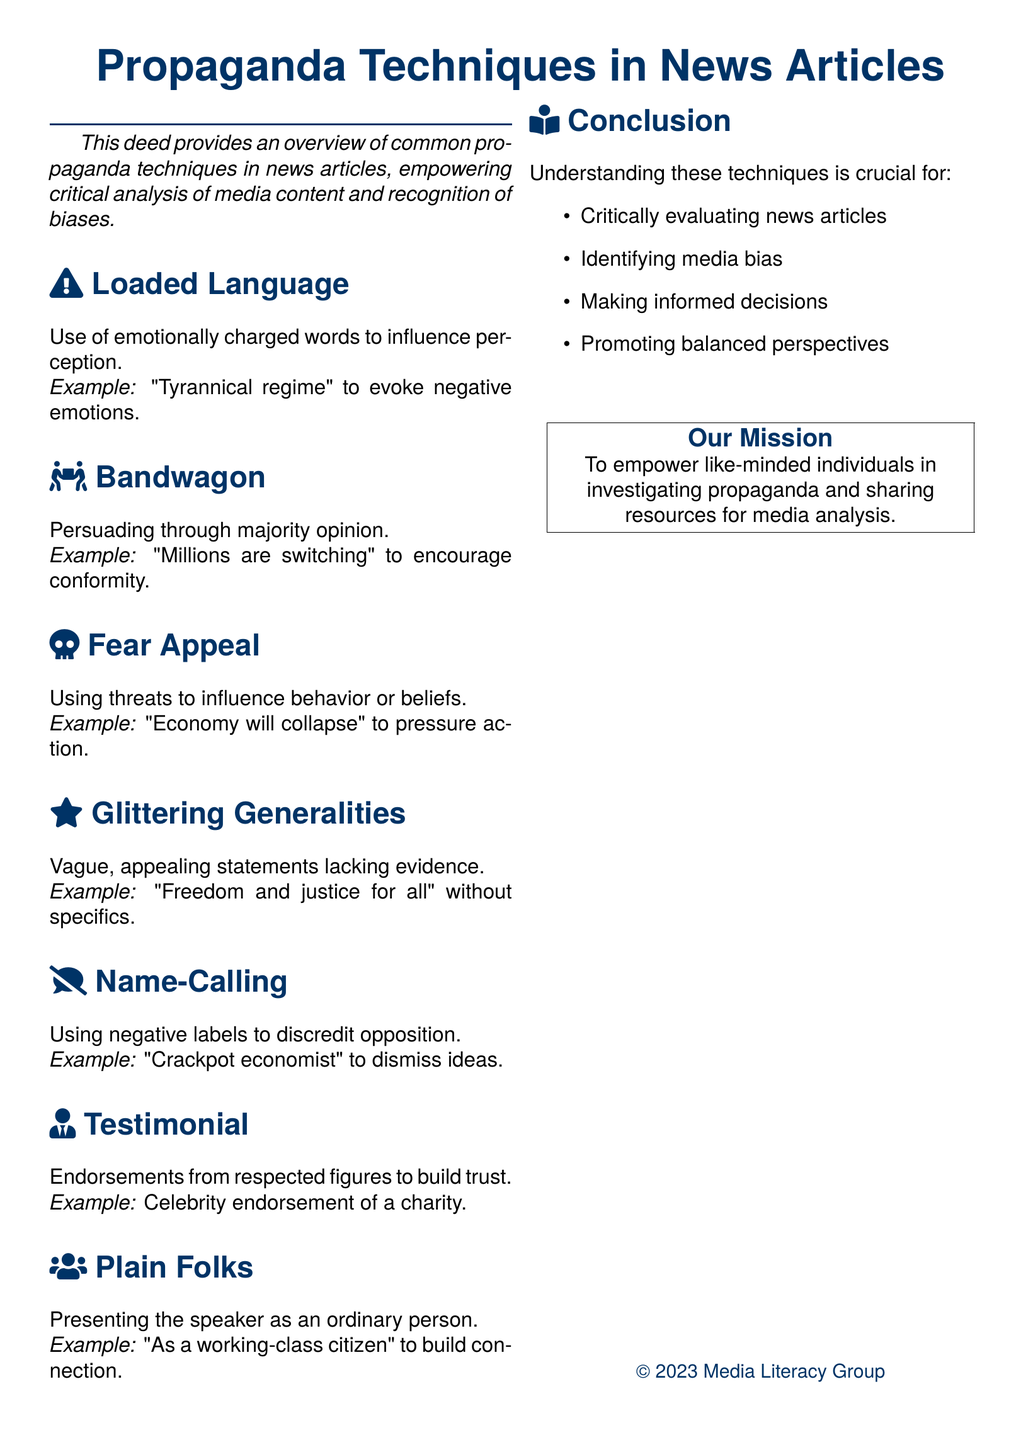What is the title of the document? The title is prominently displayed at the center of the document.
Answer: Propaganda Techniques in News Articles What technique involves the use of emotionally charged words? This technique is explicitly named in the document with an example provided.
Answer: Loaded Language Which example is given for the Bandwagon technique? A specific phrase is mentioned to illustrate the Bandwagon technique.
Answer: Millions are switching What is a common purpose mentioned in the Conclusion? This purpose is listed under key points that summarize the aims of understanding propaganda techniques.
Answer: Critically evaluating news articles What kind of appeal does "Economy will collapse" represent? The document classifies this phrase under a specific propaganda technique.
Answer: Fear Appeal How many propaganda techniques are discussed in the document? The document lists out different techniques which can be counted.
Answer: Six What is the mission statement of the group? The mission is emphasized in a dedicated section which captures the essence of their goals.
Answer: To empower like-minded individuals in investigating propaganda and sharing resources for media analysis Which technique uses negative labels? This technique is identified specifically within the document and is associated with discrediting opposition.
Answer: Name-Calling What color is used for the headings? The document specifies a color scheme for the headings which is mentioned in the formatting section.
Answer: Dark blue 